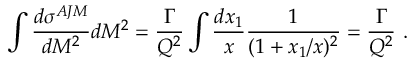<formula> <loc_0><loc_0><loc_500><loc_500>\int { \frac { d \sigma ^ { A J M } } { d M ^ { 2 } } } d M ^ { 2 } = { \frac { \Gamma } { Q ^ { 2 } } } \int { \frac { d x _ { 1 } } { x } } { \frac { 1 } { ( 1 + x _ { 1 } / x ) ^ { 2 } } } = { \frac { \Gamma } { Q ^ { 2 } } } \ .</formula> 